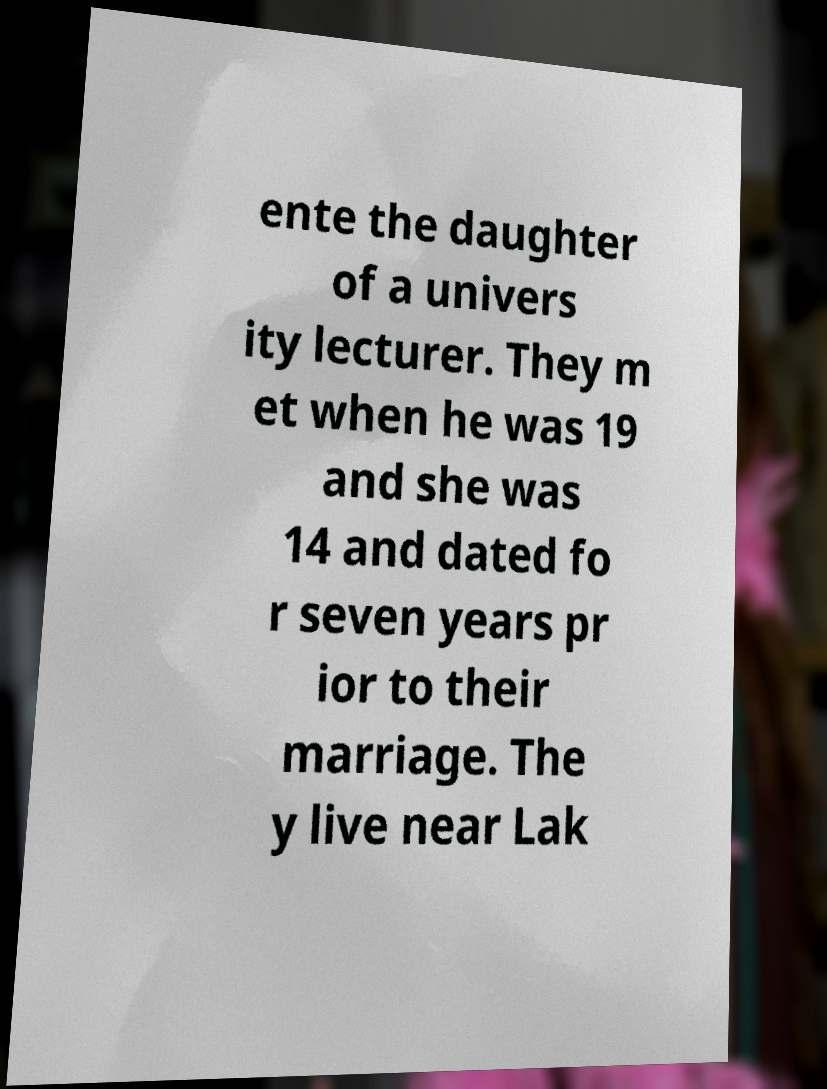Can you accurately transcribe the text from the provided image for me? ente the daughter of a univers ity lecturer. They m et when he was 19 and she was 14 and dated fo r seven years pr ior to their marriage. The y live near Lak 